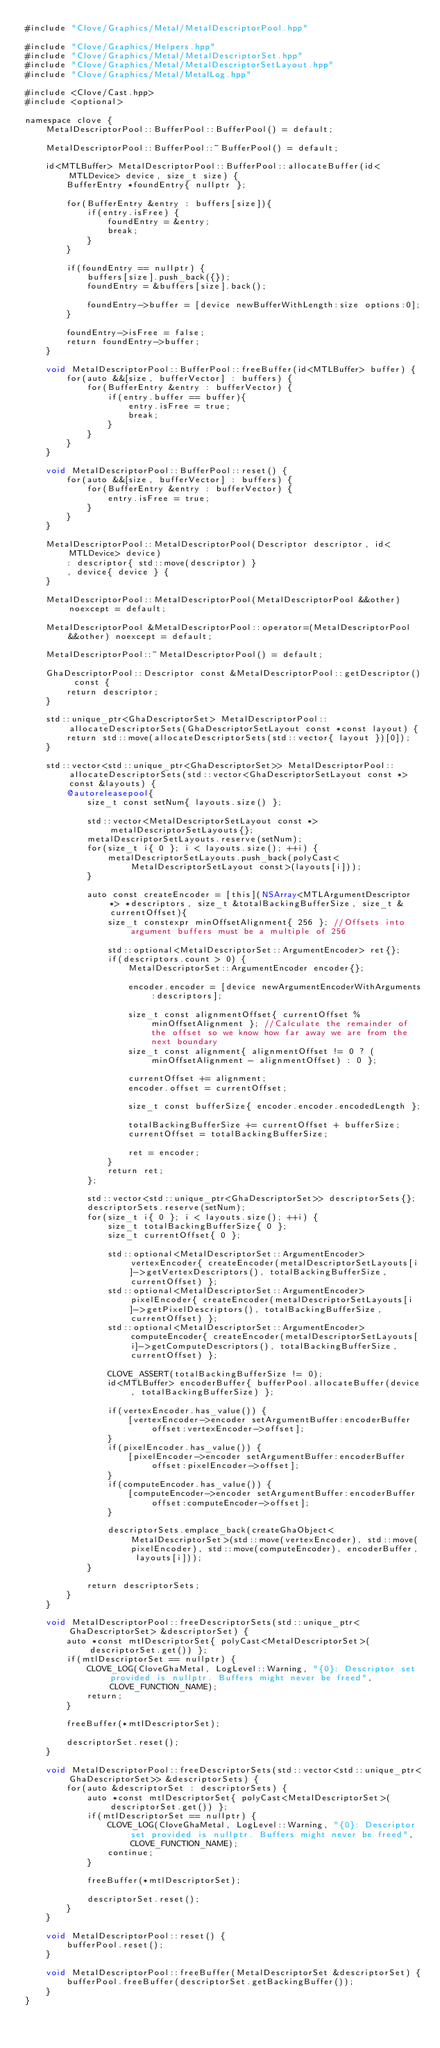Convert code to text. <code><loc_0><loc_0><loc_500><loc_500><_ObjectiveC_>#include "Clove/Graphics/Metal/MetalDescriptorPool.hpp"

#include "Clove/Graphics/Helpers.hpp"
#include "Clove/Graphics/Metal/MetalDescriptorSet.hpp"
#include "Clove/Graphics/Metal/MetalDescriptorSetLayout.hpp"
#include "Clove/Graphics/Metal/MetalLog.hpp"

#include <Clove/Cast.hpp>
#include <optional>

namespace clove {
    MetalDescriptorPool::BufferPool::BufferPool() = default;
    
    MetalDescriptorPool::BufferPool::~BufferPool() = default;
    
    id<MTLBuffer> MetalDescriptorPool::BufferPool::allocateBuffer(id<MTLDevice> device, size_t size) {
        BufferEntry *foundEntry{ nullptr };
        
        for(BufferEntry &entry : buffers[size]){
            if(entry.isFree) {
                foundEntry = &entry;
                break;
            }
        }
        
        if(foundEntry == nullptr) {
            buffers[size].push_back({});
            foundEntry = &buffers[size].back();
            
            foundEntry->buffer = [device newBufferWithLength:size options:0];
        }
        
        foundEntry->isFree = false;
        return foundEntry->buffer;
    }
    
    void MetalDescriptorPool::BufferPool::freeBuffer(id<MTLBuffer> buffer) {
        for(auto &&[size, bufferVector] : buffers) {
            for(BufferEntry &entry : bufferVector) {
                if(entry.buffer == buffer){
                    entry.isFree = true;
                    break;
                }
            }
        }
    }
    
    void MetalDescriptorPool::BufferPool::reset() {
        for(auto &&[size, bufferVector] : buffers) {
            for(BufferEntry &entry : bufferVector) {
                entry.isFree = true;
            }
        }
    }
    
    MetalDescriptorPool::MetalDescriptorPool(Descriptor descriptor, id<MTLDevice> device)
        : descriptor{ std::move(descriptor) }
        , device{ device } {
    }
    
    MetalDescriptorPool::MetalDescriptorPool(MetalDescriptorPool &&other) noexcept = default;
    
    MetalDescriptorPool &MetalDescriptorPool::operator=(MetalDescriptorPool &&other) noexcept = default;
    
    MetalDescriptorPool::~MetalDescriptorPool() = default;
    
    GhaDescriptorPool::Descriptor const &MetalDescriptorPool::getDescriptor() const {
        return descriptor;
    }
    
    std::unique_ptr<GhaDescriptorSet> MetalDescriptorPool::allocateDescriptorSets(GhaDescriptorSetLayout const *const layout) {
        return std::move(allocateDescriptorSets(std::vector{ layout })[0]);
    }
    
    std::vector<std::unique_ptr<GhaDescriptorSet>> MetalDescriptorPool::allocateDescriptorSets(std::vector<GhaDescriptorSetLayout const *> const &layouts) {
        @autoreleasepool{
            size_t const setNum{ layouts.size() };
            
            std::vector<MetalDescriptorSetLayout const *> metalDescriptorSetLayouts{};
            metalDescriptorSetLayouts.reserve(setNum);
            for(size_t i{ 0 }; i < layouts.size(); ++i) {
                metalDescriptorSetLayouts.push_back(polyCast<MetalDescriptorSetLayout const>(layouts[i]));
            }
            
            auto const createEncoder = [this](NSArray<MTLArgumentDescriptor *> *descriptors, size_t &totalBackingBufferSize, size_t &currentOffset){
                size_t constexpr minOffsetAlignment{ 256 }; //Offsets into argument buffers must be a multiple of 256
                
                std::optional<MetalDescriptorSet::ArgumentEncoder> ret{};
                if(descriptors.count > 0) {
                    MetalDescriptorSet::ArgumentEncoder encoder{};
                    
                    encoder.encoder = [device newArgumentEncoderWithArguments:descriptors];
                    
                    size_t const alignmentOffset{ currentOffset % minOffsetAlignment }; //Calculate the remainder of the offset so we know how far away we are from the next boundary
                    size_t const alignment{ alignmentOffset != 0 ? (minOffsetAlignment - alignmentOffset) : 0 };
                    
                    currentOffset += alignment;
                    encoder.offset = currentOffset;
                    
                    size_t const bufferSize{ encoder.encoder.encodedLength };
                    
                    totalBackingBufferSize += currentOffset + bufferSize;
                    currentOffset = totalBackingBufferSize;

                    ret = encoder;
                }
                return ret;
            };
            
            std::vector<std::unique_ptr<GhaDescriptorSet>> descriptorSets{};
            descriptorSets.reserve(setNum);
            for(size_t i{ 0 }; i < layouts.size(); ++i) {
                size_t totalBackingBufferSize{ 0 };
                size_t currentOffset{ 0 };
                
                std::optional<MetalDescriptorSet::ArgumentEncoder> vertexEncoder{ createEncoder(metalDescriptorSetLayouts[i]->getVertexDescriptors(), totalBackingBufferSize, currentOffset) };
                std::optional<MetalDescriptorSet::ArgumentEncoder> pixelEncoder{ createEncoder(metalDescriptorSetLayouts[i]->getPixelDescriptors(), totalBackingBufferSize, currentOffset) };
                std::optional<MetalDescriptorSet::ArgumentEncoder> computeEncoder{ createEncoder(metalDescriptorSetLayouts[i]->getComputeDescriptors(), totalBackingBufferSize, currentOffset) };
                
                CLOVE_ASSERT(totalBackingBufferSize != 0);
                id<MTLBuffer> encoderBuffer{ bufferPool.allocateBuffer(device, totalBackingBufferSize) };
                
                if(vertexEncoder.has_value()) {
                    [vertexEncoder->encoder setArgumentBuffer:encoderBuffer offset:vertexEncoder->offset];
                }
                if(pixelEncoder.has_value()) {
                    [pixelEncoder->encoder setArgumentBuffer:encoderBuffer offset:pixelEncoder->offset];
                }
                if(computeEncoder.has_value()) {
                    [computeEncoder->encoder setArgumentBuffer:encoderBuffer offset:computeEncoder->offset];
                }
                
                descriptorSets.emplace_back(createGhaObject<MetalDescriptorSet>(std::move(vertexEncoder), std::move(pixelEncoder), std::move(computeEncoder), encoderBuffer, layouts[i]));
            }
            
            return descriptorSets;
        }
    }
    
    void MetalDescriptorPool::freeDescriptorSets(std::unique_ptr<GhaDescriptorSet> &descriptorSet) {
        auto *const mtlDescriptorSet{ polyCast<MetalDescriptorSet>(descriptorSet.get()) };
        if(mtlDescriptorSet == nullptr) {
            CLOVE_LOG(CloveGhaMetal, LogLevel::Warning, "{0}: Descriptor set provided is nullptr. Buffers might never be freed", CLOVE_FUNCTION_NAME);
            return;
        }

        freeBuffer(*mtlDescriptorSet);

        descriptorSet.reset();
    }
    
    void MetalDescriptorPool::freeDescriptorSets(std::vector<std::unique_ptr<GhaDescriptorSet>> &descriptorSets) {
        for(auto &descriptorSet : descriptorSets) {
            auto *const mtlDescriptorSet{ polyCast<MetalDescriptorSet>(descriptorSet.get()) };
            if(mtlDescriptorSet == nullptr) {
                CLOVE_LOG(CloveGhaMetal, LogLevel::Warning, "{0}: Descriptor set provided is nullptr. Buffers might never be freed", CLOVE_FUNCTION_NAME);
                continue;
            }

            freeBuffer(*mtlDescriptorSet);

            descriptorSet.reset();
        }
    }
    
    void MetalDescriptorPool::reset() {
        bufferPool.reset();
    }

    void MetalDescriptorPool::freeBuffer(MetalDescriptorSet &descriptorSet) {
        bufferPool.freeBuffer(descriptorSet.getBackingBuffer());
    }
}
</code> 